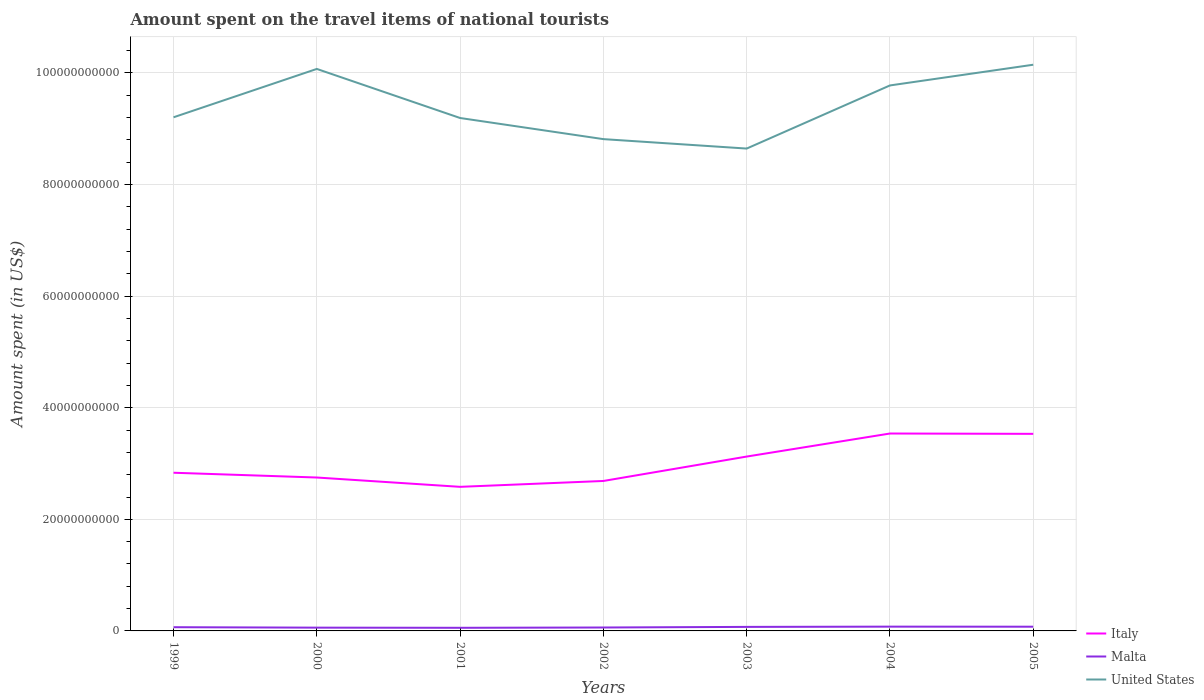How many different coloured lines are there?
Your answer should be very brief. 3. Does the line corresponding to Malta intersect with the line corresponding to Italy?
Give a very brief answer. No. Across all years, what is the maximum amount spent on the travel items of national tourists in United States?
Give a very brief answer. 8.64e+1. In which year was the amount spent on the travel items of national tourists in Malta maximum?
Ensure brevity in your answer.  2001. What is the total amount spent on the travel items of national tourists in United States in the graph?
Your answer should be very brief. -1.50e+1. What is the difference between the highest and the second highest amount spent on the travel items of national tourists in Italy?
Your answer should be compact. 9.56e+09. What is the difference between the highest and the lowest amount spent on the travel items of national tourists in United States?
Your answer should be compact. 3. What is the difference between two consecutive major ticks on the Y-axis?
Provide a succinct answer. 2.00e+1. Are the values on the major ticks of Y-axis written in scientific E-notation?
Your answer should be compact. No. Does the graph contain any zero values?
Provide a short and direct response. No. Where does the legend appear in the graph?
Ensure brevity in your answer.  Bottom right. What is the title of the graph?
Ensure brevity in your answer.  Amount spent on the travel items of national tourists. Does "Gabon" appear as one of the legend labels in the graph?
Keep it short and to the point. No. What is the label or title of the Y-axis?
Provide a short and direct response. Amount spent (in US$). What is the Amount spent (in US$) in Italy in 1999?
Give a very brief answer. 2.84e+1. What is the Amount spent (in US$) of Malta in 1999?
Ensure brevity in your answer.  6.67e+08. What is the Amount spent (in US$) in United States in 1999?
Offer a very short reply. 9.20e+1. What is the Amount spent (in US$) of Italy in 2000?
Offer a terse response. 2.75e+1. What is the Amount spent (in US$) in Malta in 2000?
Your answer should be compact. 5.87e+08. What is the Amount spent (in US$) of United States in 2000?
Offer a very short reply. 1.01e+11. What is the Amount spent (in US$) of Italy in 2001?
Your response must be concise. 2.58e+1. What is the Amount spent (in US$) of Malta in 2001?
Give a very brief answer. 5.61e+08. What is the Amount spent (in US$) in United States in 2001?
Your answer should be compact. 9.19e+1. What is the Amount spent (in US$) of Italy in 2002?
Provide a short and direct response. 2.69e+1. What is the Amount spent (in US$) in Malta in 2002?
Give a very brief answer. 6.14e+08. What is the Amount spent (in US$) in United States in 2002?
Provide a short and direct response. 8.81e+1. What is the Amount spent (in US$) of Italy in 2003?
Keep it short and to the point. 3.12e+1. What is the Amount spent (in US$) in Malta in 2003?
Offer a terse response. 7.22e+08. What is the Amount spent (in US$) in United States in 2003?
Offer a terse response. 8.64e+1. What is the Amount spent (in US$) of Italy in 2004?
Your answer should be very brief. 3.54e+1. What is the Amount spent (in US$) in Malta in 2004?
Keep it short and to the point. 7.67e+08. What is the Amount spent (in US$) of United States in 2004?
Your answer should be compact. 9.78e+1. What is the Amount spent (in US$) of Italy in 2005?
Your answer should be compact. 3.53e+1. What is the Amount spent (in US$) in Malta in 2005?
Offer a very short reply. 7.55e+08. What is the Amount spent (in US$) in United States in 2005?
Give a very brief answer. 1.01e+11. Across all years, what is the maximum Amount spent (in US$) in Italy?
Your answer should be very brief. 3.54e+1. Across all years, what is the maximum Amount spent (in US$) in Malta?
Give a very brief answer. 7.67e+08. Across all years, what is the maximum Amount spent (in US$) of United States?
Keep it short and to the point. 1.01e+11. Across all years, what is the minimum Amount spent (in US$) of Italy?
Your response must be concise. 2.58e+1. Across all years, what is the minimum Amount spent (in US$) of Malta?
Keep it short and to the point. 5.61e+08. Across all years, what is the minimum Amount spent (in US$) of United States?
Your answer should be compact. 8.64e+1. What is the total Amount spent (in US$) of Italy in the graph?
Offer a very short reply. 2.10e+11. What is the total Amount spent (in US$) of Malta in the graph?
Ensure brevity in your answer.  4.67e+09. What is the total Amount spent (in US$) of United States in the graph?
Give a very brief answer. 6.58e+11. What is the difference between the Amount spent (in US$) of Italy in 1999 and that in 2000?
Offer a very short reply. 8.57e+08. What is the difference between the Amount spent (in US$) of Malta in 1999 and that in 2000?
Ensure brevity in your answer.  8.00e+07. What is the difference between the Amount spent (in US$) of United States in 1999 and that in 2000?
Your answer should be very brief. -8.67e+09. What is the difference between the Amount spent (in US$) of Italy in 1999 and that in 2001?
Offer a very short reply. 2.53e+09. What is the difference between the Amount spent (in US$) of Malta in 1999 and that in 2001?
Your answer should be very brief. 1.06e+08. What is the difference between the Amount spent (in US$) of United States in 1999 and that in 2001?
Ensure brevity in your answer.  1.28e+08. What is the difference between the Amount spent (in US$) of Italy in 1999 and that in 2002?
Make the answer very short. 1.48e+09. What is the difference between the Amount spent (in US$) of Malta in 1999 and that in 2002?
Ensure brevity in your answer.  5.30e+07. What is the difference between the Amount spent (in US$) of United States in 1999 and that in 2002?
Make the answer very short. 3.91e+09. What is the difference between the Amount spent (in US$) of Italy in 1999 and that in 2003?
Your answer should be compact. -2.90e+09. What is the difference between the Amount spent (in US$) in Malta in 1999 and that in 2003?
Give a very brief answer. -5.50e+07. What is the difference between the Amount spent (in US$) of United States in 1999 and that in 2003?
Your response must be concise. 5.61e+09. What is the difference between the Amount spent (in US$) in Italy in 1999 and that in 2004?
Provide a short and direct response. -7.03e+09. What is the difference between the Amount spent (in US$) in Malta in 1999 and that in 2004?
Offer a very short reply. -1.00e+08. What is the difference between the Amount spent (in US$) in United States in 1999 and that in 2004?
Keep it short and to the point. -5.71e+09. What is the difference between the Amount spent (in US$) of Italy in 1999 and that in 2005?
Your answer should be compact. -6.97e+09. What is the difference between the Amount spent (in US$) in Malta in 1999 and that in 2005?
Offer a very short reply. -8.80e+07. What is the difference between the Amount spent (in US$) of United States in 1999 and that in 2005?
Give a very brief answer. -9.42e+09. What is the difference between the Amount spent (in US$) in Italy in 2000 and that in 2001?
Your answer should be compact. 1.67e+09. What is the difference between the Amount spent (in US$) in Malta in 2000 and that in 2001?
Your answer should be compact. 2.60e+07. What is the difference between the Amount spent (in US$) in United States in 2000 and that in 2001?
Offer a very short reply. 8.79e+09. What is the difference between the Amount spent (in US$) in Italy in 2000 and that in 2002?
Your answer should be very brief. 6.20e+08. What is the difference between the Amount spent (in US$) of Malta in 2000 and that in 2002?
Your answer should be compact. -2.70e+07. What is the difference between the Amount spent (in US$) of United States in 2000 and that in 2002?
Offer a terse response. 1.26e+1. What is the difference between the Amount spent (in US$) in Italy in 2000 and that in 2003?
Offer a terse response. -3.75e+09. What is the difference between the Amount spent (in US$) in Malta in 2000 and that in 2003?
Provide a short and direct response. -1.35e+08. What is the difference between the Amount spent (in US$) of United States in 2000 and that in 2003?
Provide a succinct answer. 1.43e+1. What is the difference between the Amount spent (in US$) of Italy in 2000 and that in 2004?
Give a very brief answer. -7.88e+09. What is the difference between the Amount spent (in US$) in Malta in 2000 and that in 2004?
Give a very brief answer. -1.80e+08. What is the difference between the Amount spent (in US$) of United States in 2000 and that in 2004?
Your response must be concise. 2.96e+09. What is the difference between the Amount spent (in US$) in Italy in 2000 and that in 2005?
Ensure brevity in your answer.  -7.83e+09. What is the difference between the Amount spent (in US$) of Malta in 2000 and that in 2005?
Give a very brief answer. -1.68e+08. What is the difference between the Amount spent (in US$) in United States in 2000 and that in 2005?
Give a very brief answer. -7.53e+08. What is the difference between the Amount spent (in US$) of Italy in 2001 and that in 2002?
Give a very brief answer. -1.05e+09. What is the difference between the Amount spent (in US$) of Malta in 2001 and that in 2002?
Give a very brief answer. -5.30e+07. What is the difference between the Amount spent (in US$) in United States in 2001 and that in 2002?
Your answer should be compact. 3.79e+09. What is the difference between the Amount spent (in US$) of Italy in 2001 and that in 2003?
Give a very brief answer. -5.42e+09. What is the difference between the Amount spent (in US$) of Malta in 2001 and that in 2003?
Offer a very short reply. -1.61e+08. What is the difference between the Amount spent (in US$) in United States in 2001 and that in 2003?
Offer a very short reply. 5.48e+09. What is the difference between the Amount spent (in US$) in Italy in 2001 and that in 2004?
Your answer should be compact. -9.56e+09. What is the difference between the Amount spent (in US$) of Malta in 2001 and that in 2004?
Keep it short and to the point. -2.06e+08. What is the difference between the Amount spent (in US$) in United States in 2001 and that in 2004?
Ensure brevity in your answer.  -5.84e+09. What is the difference between the Amount spent (in US$) in Italy in 2001 and that in 2005?
Provide a succinct answer. -9.50e+09. What is the difference between the Amount spent (in US$) in Malta in 2001 and that in 2005?
Offer a very short reply. -1.94e+08. What is the difference between the Amount spent (in US$) in United States in 2001 and that in 2005?
Give a very brief answer. -9.55e+09. What is the difference between the Amount spent (in US$) of Italy in 2002 and that in 2003?
Give a very brief answer. -4.37e+09. What is the difference between the Amount spent (in US$) of Malta in 2002 and that in 2003?
Offer a terse response. -1.08e+08. What is the difference between the Amount spent (in US$) of United States in 2002 and that in 2003?
Give a very brief answer. 1.69e+09. What is the difference between the Amount spent (in US$) of Italy in 2002 and that in 2004?
Provide a short and direct response. -8.50e+09. What is the difference between the Amount spent (in US$) in Malta in 2002 and that in 2004?
Provide a short and direct response. -1.53e+08. What is the difference between the Amount spent (in US$) of United States in 2002 and that in 2004?
Offer a very short reply. -9.62e+09. What is the difference between the Amount spent (in US$) in Italy in 2002 and that in 2005?
Keep it short and to the point. -8.45e+09. What is the difference between the Amount spent (in US$) of Malta in 2002 and that in 2005?
Your response must be concise. -1.41e+08. What is the difference between the Amount spent (in US$) of United States in 2002 and that in 2005?
Make the answer very short. -1.33e+1. What is the difference between the Amount spent (in US$) of Italy in 2003 and that in 2004?
Offer a very short reply. -4.13e+09. What is the difference between the Amount spent (in US$) of Malta in 2003 and that in 2004?
Ensure brevity in your answer.  -4.50e+07. What is the difference between the Amount spent (in US$) in United States in 2003 and that in 2004?
Your answer should be compact. -1.13e+1. What is the difference between the Amount spent (in US$) of Italy in 2003 and that in 2005?
Your answer should be very brief. -4.07e+09. What is the difference between the Amount spent (in US$) in Malta in 2003 and that in 2005?
Keep it short and to the point. -3.30e+07. What is the difference between the Amount spent (in US$) in United States in 2003 and that in 2005?
Your answer should be very brief. -1.50e+1. What is the difference between the Amount spent (in US$) in Italy in 2004 and that in 2005?
Your response must be concise. 5.90e+07. What is the difference between the Amount spent (in US$) in United States in 2004 and that in 2005?
Ensure brevity in your answer.  -3.71e+09. What is the difference between the Amount spent (in US$) in Italy in 1999 and the Amount spent (in US$) in Malta in 2000?
Your response must be concise. 2.78e+1. What is the difference between the Amount spent (in US$) in Italy in 1999 and the Amount spent (in US$) in United States in 2000?
Make the answer very short. -7.24e+1. What is the difference between the Amount spent (in US$) of Malta in 1999 and the Amount spent (in US$) of United States in 2000?
Offer a terse response. -1.00e+11. What is the difference between the Amount spent (in US$) in Italy in 1999 and the Amount spent (in US$) in Malta in 2001?
Offer a terse response. 2.78e+1. What is the difference between the Amount spent (in US$) in Italy in 1999 and the Amount spent (in US$) in United States in 2001?
Keep it short and to the point. -6.36e+1. What is the difference between the Amount spent (in US$) of Malta in 1999 and the Amount spent (in US$) of United States in 2001?
Provide a succinct answer. -9.13e+1. What is the difference between the Amount spent (in US$) in Italy in 1999 and the Amount spent (in US$) in Malta in 2002?
Your response must be concise. 2.77e+1. What is the difference between the Amount spent (in US$) in Italy in 1999 and the Amount spent (in US$) in United States in 2002?
Provide a succinct answer. -5.98e+1. What is the difference between the Amount spent (in US$) of Malta in 1999 and the Amount spent (in US$) of United States in 2002?
Your answer should be very brief. -8.75e+1. What is the difference between the Amount spent (in US$) of Italy in 1999 and the Amount spent (in US$) of Malta in 2003?
Your response must be concise. 2.76e+1. What is the difference between the Amount spent (in US$) of Italy in 1999 and the Amount spent (in US$) of United States in 2003?
Ensure brevity in your answer.  -5.81e+1. What is the difference between the Amount spent (in US$) in Malta in 1999 and the Amount spent (in US$) in United States in 2003?
Provide a succinct answer. -8.58e+1. What is the difference between the Amount spent (in US$) of Italy in 1999 and the Amount spent (in US$) of Malta in 2004?
Make the answer very short. 2.76e+1. What is the difference between the Amount spent (in US$) in Italy in 1999 and the Amount spent (in US$) in United States in 2004?
Ensure brevity in your answer.  -6.94e+1. What is the difference between the Amount spent (in US$) in Malta in 1999 and the Amount spent (in US$) in United States in 2004?
Your answer should be very brief. -9.71e+1. What is the difference between the Amount spent (in US$) in Italy in 1999 and the Amount spent (in US$) in Malta in 2005?
Offer a terse response. 2.76e+1. What is the difference between the Amount spent (in US$) in Italy in 1999 and the Amount spent (in US$) in United States in 2005?
Make the answer very short. -7.31e+1. What is the difference between the Amount spent (in US$) in Malta in 1999 and the Amount spent (in US$) in United States in 2005?
Give a very brief answer. -1.01e+11. What is the difference between the Amount spent (in US$) in Italy in 2000 and the Amount spent (in US$) in Malta in 2001?
Your answer should be compact. 2.69e+1. What is the difference between the Amount spent (in US$) in Italy in 2000 and the Amount spent (in US$) in United States in 2001?
Provide a succinct answer. -6.44e+1. What is the difference between the Amount spent (in US$) in Malta in 2000 and the Amount spent (in US$) in United States in 2001?
Your answer should be compact. -9.13e+1. What is the difference between the Amount spent (in US$) of Italy in 2000 and the Amount spent (in US$) of Malta in 2002?
Ensure brevity in your answer.  2.69e+1. What is the difference between the Amount spent (in US$) of Italy in 2000 and the Amount spent (in US$) of United States in 2002?
Offer a very short reply. -6.06e+1. What is the difference between the Amount spent (in US$) of Malta in 2000 and the Amount spent (in US$) of United States in 2002?
Keep it short and to the point. -8.75e+1. What is the difference between the Amount spent (in US$) of Italy in 2000 and the Amount spent (in US$) of Malta in 2003?
Provide a succinct answer. 2.68e+1. What is the difference between the Amount spent (in US$) in Italy in 2000 and the Amount spent (in US$) in United States in 2003?
Your answer should be very brief. -5.90e+1. What is the difference between the Amount spent (in US$) in Malta in 2000 and the Amount spent (in US$) in United States in 2003?
Make the answer very short. -8.59e+1. What is the difference between the Amount spent (in US$) in Italy in 2000 and the Amount spent (in US$) in Malta in 2004?
Your response must be concise. 2.67e+1. What is the difference between the Amount spent (in US$) in Italy in 2000 and the Amount spent (in US$) in United States in 2004?
Your response must be concise. -7.03e+1. What is the difference between the Amount spent (in US$) of Malta in 2000 and the Amount spent (in US$) of United States in 2004?
Keep it short and to the point. -9.72e+1. What is the difference between the Amount spent (in US$) of Italy in 2000 and the Amount spent (in US$) of Malta in 2005?
Ensure brevity in your answer.  2.67e+1. What is the difference between the Amount spent (in US$) in Italy in 2000 and the Amount spent (in US$) in United States in 2005?
Provide a short and direct response. -7.40e+1. What is the difference between the Amount spent (in US$) of Malta in 2000 and the Amount spent (in US$) of United States in 2005?
Give a very brief answer. -1.01e+11. What is the difference between the Amount spent (in US$) of Italy in 2001 and the Amount spent (in US$) of Malta in 2002?
Give a very brief answer. 2.52e+1. What is the difference between the Amount spent (in US$) in Italy in 2001 and the Amount spent (in US$) in United States in 2002?
Offer a terse response. -6.23e+1. What is the difference between the Amount spent (in US$) in Malta in 2001 and the Amount spent (in US$) in United States in 2002?
Keep it short and to the point. -8.76e+1. What is the difference between the Amount spent (in US$) of Italy in 2001 and the Amount spent (in US$) of Malta in 2003?
Provide a short and direct response. 2.51e+1. What is the difference between the Amount spent (in US$) of Italy in 2001 and the Amount spent (in US$) of United States in 2003?
Provide a succinct answer. -6.06e+1. What is the difference between the Amount spent (in US$) in Malta in 2001 and the Amount spent (in US$) in United States in 2003?
Keep it short and to the point. -8.59e+1. What is the difference between the Amount spent (in US$) in Italy in 2001 and the Amount spent (in US$) in Malta in 2004?
Make the answer very short. 2.51e+1. What is the difference between the Amount spent (in US$) of Italy in 2001 and the Amount spent (in US$) of United States in 2004?
Your answer should be very brief. -7.19e+1. What is the difference between the Amount spent (in US$) of Malta in 2001 and the Amount spent (in US$) of United States in 2004?
Keep it short and to the point. -9.72e+1. What is the difference between the Amount spent (in US$) of Italy in 2001 and the Amount spent (in US$) of Malta in 2005?
Ensure brevity in your answer.  2.51e+1. What is the difference between the Amount spent (in US$) in Italy in 2001 and the Amount spent (in US$) in United States in 2005?
Keep it short and to the point. -7.56e+1. What is the difference between the Amount spent (in US$) of Malta in 2001 and the Amount spent (in US$) of United States in 2005?
Your answer should be compact. -1.01e+11. What is the difference between the Amount spent (in US$) of Italy in 2002 and the Amount spent (in US$) of Malta in 2003?
Ensure brevity in your answer.  2.62e+1. What is the difference between the Amount spent (in US$) of Italy in 2002 and the Amount spent (in US$) of United States in 2003?
Your response must be concise. -5.96e+1. What is the difference between the Amount spent (in US$) in Malta in 2002 and the Amount spent (in US$) in United States in 2003?
Offer a very short reply. -8.58e+1. What is the difference between the Amount spent (in US$) of Italy in 2002 and the Amount spent (in US$) of Malta in 2004?
Keep it short and to the point. 2.61e+1. What is the difference between the Amount spent (in US$) in Italy in 2002 and the Amount spent (in US$) in United States in 2004?
Offer a very short reply. -7.09e+1. What is the difference between the Amount spent (in US$) in Malta in 2002 and the Amount spent (in US$) in United States in 2004?
Your response must be concise. -9.71e+1. What is the difference between the Amount spent (in US$) of Italy in 2002 and the Amount spent (in US$) of Malta in 2005?
Your answer should be very brief. 2.61e+1. What is the difference between the Amount spent (in US$) of Italy in 2002 and the Amount spent (in US$) of United States in 2005?
Make the answer very short. -7.46e+1. What is the difference between the Amount spent (in US$) of Malta in 2002 and the Amount spent (in US$) of United States in 2005?
Your answer should be compact. -1.01e+11. What is the difference between the Amount spent (in US$) of Italy in 2003 and the Amount spent (in US$) of Malta in 2004?
Provide a succinct answer. 3.05e+1. What is the difference between the Amount spent (in US$) in Italy in 2003 and the Amount spent (in US$) in United States in 2004?
Provide a short and direct response. -6.65e+1. What is the difference between the Amount spent (in US$) in Malta in 2003 and the Amount spent (in US$) in United States in 2004?
Provide a succinct answer. -9.70e+1. What is the difference between the Amount spent (in US$) of Italy in 2003 and the Amount spent (in US$) of Malta in 2005?
Ensure brevity in your answer.  3.05e+1. What is the difference between the Amount spent (in US$) in Italy in 2003 and the Amount spent (in US$) in United States in 2005?
Provide a succinct answer. -7.02e+1. What is the difference between the Amount spent (in US$) in Malta in 2003 and the Amount spent (in US$) in United States in 2005?
Your answer should be very brief. -1.01e+11. What is the difference between the Amount spent (in US$) of Italy in 2004 and the Amount spent (in US$) of Malta in 2005?
Make the answer very short. 3.46e+1. What is the difference between the Amount spent (in US$) in Italy in 2004 and the Amount spent (in US$) in United States in 2005?
Ensure brevity in your answer.  -6.61e+1. What is the difference between the Amount spent (in US$) in Malta in 2004 and the Amount spent (in US$) in United States in 2005?
Your answer should be very brief. -1.01e+11. What is the average Amount spent (in US$) of Italy per year?
Provide a succinct answer. 3.01e+1. What is the average Amount spent (in US$) of Malta per year?
Make the answer very short. 6.68e+08. What is the average Amount spent (in US$) in United States per year?
Offer a very short reply. 9.41e+1. In the year 1999, what is the difference between the Amount spent (in US$) in Italy and Amount spent (in US$) in Malta?
Provide a short and direct response. 2.77e+1. In the year 1999, what is the difference between the Amount spent (in US$) in Italy and Amount spent (in US$) in United States?
Offer a very short reply. -6.37e+1. In the year 1999, what is the difference between the Amount spent (in US$) in Malta and Amount spent (in US$) in United States?
Provide a short and direct response. -9.14e+1. In the year 2000, what is the difference between the Amount spent (in US$) in Italy and Amount spent (in US$) in Malta?
Your answer should be very brief. 2.69e+1. In the year 2000, what is the difference between the Amount spent (in US$) in Italy and Amount spent (in US$) in United States?
Provide a short and direct response. -7.32e+1. In the year 2000, what is the difference between the Amount spent (in US$) in Malta and Amount spent (in US$) in United States?
Offer a very short reply. -1.00e+11. In the year 2001, what is the difference between the Amount spent (in US$) of Italy and Amount spent (in US$) of Malta?
Offer a very short reply. 2.53e+1. In the year 2001, what is the difference between the Amount spent (in US$) in Italy and Amount spent (in US$) in United States?
Provide a short and direct response. -6.61e+1. In the year 2001, what is the difference between the Amount spent (in US$) in Malta and Amount spent (in US$) in United States?
Make the answer very short. -9.14e+1. In the year 2002, what is the difference between the Amount spent (in US$) of Italy and Amount spent (in US$) of Malta?
Give a very brief answer. 2.63e+1. In the year 2002, what is the difference between the Amount spent (in US$) in Italy and Amount spent (in US$) in United States?
Offer a terse response. -6.13e+1. In the year 2002, what is the difference between the Amount spent (in US$) of Malta and Amount spent (in US$) of United States?
Offer a terse response. -8.75e+1. In the year 2003, what is the difference between the Amount spent (in US$) in Italy and Amount spent (in US$) in Malta?
Offer a very short reply. 3.05e+1. In the year 2003, what is the difference between the Amount spent (in US$) of Italy and Amount spent (in US$) of United States?
Your answer should be very brief. -5.52e+1. In the year 2003, what is the difference between the Amount spent (in US$) of Malta and Amount spent (in US$) of United States?
Ensure brevity in your answer.  -8.57e+1. In the year 2004, what is the difference between the Amount spent (in US$) in Italy and Amount spent (in US$) in Malta?
Ensure brevity in your answer.  3.46e+1. In the year 2004, what is the difference between the Amount spent (in US$) of Italy and Amount spent (in US$) of United States?
Give a very brief answer. -6.24e+1. In the year 2004, what is the difference between the Amount spent (in US$) of Malta and Amount spent (in US$) of United States?
Provide a succinct answer. -9.70e+1. In the year 2005, what is the difference between the Amount spent (in US$) of Italy and Amount spent (in US$) of Malta?
Your answer should be very brief. 3.46e+1. In the year 2005, what is the difference between the Amount spent (in US$) of Italy and Amount spent (in US$) of United States?
Provide a short and direct response. -6.62e+1. In the year 2005, what is the difference between the Amount spent (in US$) in Malta and Amount spent (in US$) in United States?
Ensure brevity in your answer.  -1.01e+11. What is the ratio of the Amount spent (in US$) of Italy in 1999 to that in 2000?
Offer a very short reply. 1.03. What is the ratio of the Amount spent (in US$) in Malta in 1999 to that in 2000?
Provide a succinct answer. 1.14. What is the ratio of the Amount spent (in US$) of United States in 1999 to that in 2000?
Keep it short and to the point. 0.91. What is the ratio of the Amount spent (in US$) in Italy in 1999 to that in 2001?
Give a very brief answer. 1.1. What is the ratio of the Amount spent (in US$) of Malta in 1999 to that in 2001?
Provide a short and direct response. 1.19. What is the ratio of the Amount spent (in US$) of Italy in 1999 to that in 2002?
Ensure brevity in your answer.  1.05. What is the ratio of the Amount spent (in US$) of Malta in 1999 to that in 2002?
Offer a very short reply. 1.09. What is the ratio of the Amount spent (in US$) in United States in 1999 to that in 2002?
Offer a very short reply. 1.04. What is the ratio of the Amount spent (in US$) in Italy in 1999 to that in 2003?
Ensure brevity in your answer.  0.91. What is the ratio of the Amount spent (in US$) of Malta in 1999 to that in 2003?
Make the answer very short. 0.92. What is the ratio of the Amount spent (in US$) of United States in 1999 to that in 2003?
Provide a short and direct response. 1.06. What is the ratio of the Amount spent (in US$) in Italy in 1999 to that in 2004?
Provide a succinct answer. 0.8. What is the ratio of the Amount spent (in US$) of Malta in 1999 to that in 2004?
Provide a short and direct response. 0.87. What is the ratio of the Amount spent (in US$) of United States in 1999 to that in 2004?
Your answer should be compact. 0.94. What is the ratio of the Amount spent (in US$) in Italy in 1999 to that in 2005?
Provide a succinct answer. 0.8. What is the ratio of the Amount spent (in US$) in Malta in 1999 to that in 2005?
Offer a very short reply. 0.88. What is the ratio of the Amount spent (in US$) in United States in 1999 to that in 2005?
Offer a terse response. 0.91. What is the ratio of the Amount spent (in US$) in Italy in 2000 to that in 2001?
Keep it short and to the point. 1.06. What is the ratio of the Amount spent (in US$) in Malta in 2000 to that in 2001?
Your answer should be compact. 1.05. What is the ratio of the Amount spent (in US$) in United States in 2000 to that in 2001?
Your response must be concise. 1.1. What is the ratio of the Amount spent (in US$) of Italy in 2000 to that in 2002?
Your answer should be very brief. 1.02. What is the ratio of the Amount spent (in US$) of Malta in 2000 to that in 2002?
Give a very brief answer. 0.96. What is the ratio of the Amount spent (in US$) of United States in 2000 to that in 2002?
Your response must be concise. 1.14. What is the ratio of the Amount spent (in US$) in Italy in 2000 to that in 2003?
Your response must be concise. 0.88. What is the ratio of the Amount spent (in US$) in Malta in 2000 to that in 2003?
Your answer should be very brief. 0.81. What is the ratio of the Amount spent (in US$) of United States in 2000 to that in 2003?
Your answer should be very brief. 1.17. What is the ratio of the Amount spent (in US$) in Italy in 2000 to that in 2004?
Offer a terse response. 0.78. What is the ratio of the Amount spent (in US$) of Malta in 2000 to that in 2004?
Keep it short and to the point. 0.77. What is the ratio of the Amount spent (in US$) of United States in 2000 to that in 2004?
Offer a very short reply. 1.03. What is the ratio of the Amount spent (in US$) of Italy in 2000 to that in 2005?
Make the answer very short. 0.78. What is the ratio of the Amount spent (in US$) of Malta in 2000 to that in 2005?
Provide a succinct answer. 0.78. What is the ratio of the Amount spent (in US$) of Italy in 2001 to that in 2002?
Make the answer very short. 0.96. What is the ratio of the Amount spent (in US$) in Malta in 2001 to that in 2002?
Your response must be concise. 0.91. What is the ratio of the Amount spent (in US$) of United States in 2001 to that in 2002?
Provide a succinct answer. 1.04. What is the ratio of the Amount spent (in US$) of Italy in 2001 to that in 2003?
Provide a succinct answer. 0.83. What is the ratio of the Amount spent (in US$) in Malta in 2001 to that in 2003?
Give a very brief answer. 0.78. What is the ratio of the Amount spent (in US$) in United States in 2001 to that in 2003?
Your answer should be compact. 1.06. What is the ratio of the Amount spent (in US$) in Italy in 2001 to that in 2004?
Provide a succinct answer. 0.73. What is the ratio of the Amount spent (in US$) of Malta in 2001 to that in 2004?
Offer a terse response. 0.73. What is the ratio of the Amount spent (in US$) in United States in 2001 to that in 2004?
Give a very brief answer. 0.94. What is the ratio of the Amount spent (in US$) in Italy in 2001 to that in 2005?
Ensure brevity in your answer.  0.73. What is the ratio of the Amount spent (in US$) in Malta in 2001 to that in 2005?
Your answer should be compact. 0.74. What is the ratio of the Amount spent (in US$) in United States in 2001 to that in 2005?
Your response must be concise. 0.91. What is the ratio of the Amount spent (in US$) in Italy in 2002 to that in 2003?
Keep it short and to the point. 0.86. What is the ratio of the Amount spent (in US$) in Malta in 2002 to that in 2003?
Make the answer very short. 0.85. What is the ratio of the Amount spent (in US$) in United States in 2002 to that in 2003?
Keep it short and to the point. 1.02. What is the ratio of the Amount spent (in US$) of Italy in 2002 to that in 2004?
Provide a succinct answer. 0.76. What is the ratio of the Amount spent (in US$) of Malta in 2002 to that in 2004?
Your answer should be very brief. 0.8. What is the ratio of the Amount spent (in US$) in United States in 2002 to that in 2004?
Your answer should be very brief. 0.9. What is the ratio of the Amount spent (in US$) of Italy in 2002 to that in 2005?
Make the answer very short. 0.76. What is the ratio of the Amount spent (in US$) in Malta in 2002 to that in 2005?
Provide a short and direct response. 0.81. What is the ratio of the Amount spent (in US$) of United States in 2002 to that in 2005?
Keep it short and to the point. 0.87. What is the ratio of the Amount spent (in US$) in Italy in 2003 to that in 2004?
Your answer should be very brief. 0.88. What is the ratio of the Amount spent (in US$) in Malta in 2003 to that in 2004?
Give a very brief answer. 0.94. What is the ratio of the Amount spent (in US$) in United States in 2003 to that in 2004?
Your answer should be very brief. 0.88. What is the ratio of the Amount spent (in US$) in Italy in 2003 to that in 2005?
Offer a terse response. 0.88. What is the ratio of the Amount spent (in US$) of Malta in 2003 to that in 2005?
Make the answer very short. 0.96. What is the ratio of the Amount spent (in US$) of United States in 2003 to that in 2005?
Offer a very short reply. 0.85. What is the ratio of the Amount spent (in US$) in Italy in 2004 to that in 2005?
Give a very brief answer. 1. What is the ratio of the Amount spent (in US$) in Malta in 2004 to that in 2005?
Keep it short and to the point. 1.02. What is the ratio of the Amount spent (in US$) of United States in 2004 to that in 2005?
Your response must be concise. 0.96. What is the difference between the highest and the second highest Amount spent (in US$) of Italy?
Provide a short and direct response. 5.90e+07. What is the difference between the highest and the second highest Amount spent (in US$) in Malta?
Your response must be concise. 1.20e+07. What is the difference between the highest and the second highest Amount spent (in US$) of United States?
Provide a succinct answer. 7.53e+08. What is the difference between the highest and the lowest Amount spent (in US$) in Italy?
Your answer should be very brief. 9.56e+09. What is the difference between the highest and the lowest Amount spent (in US$) in Malta?
Keep it short and to the point. 2.06e+08. What is the difference between the highest and the lowest Amount spent (in US$) of United States?
Provide a short and direct response. 1.50e+1. 